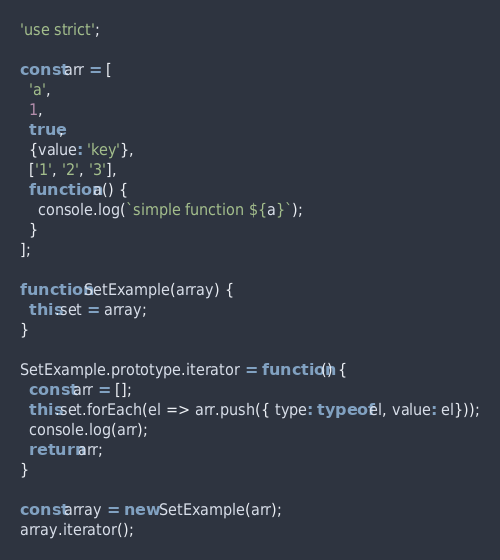<code> <loc_0><loc_0><loc_500><loc_500><_JavaScript_>'use strict';

const arr = [
  'a',
  1,
  true, 
  {value: 'key'},
  ['1', '2', '3'], 
  function a() {
    console.log(`simple function ${a}`);
  }
];

function SetExample(array) {
  this.set = array;
}

SetExample.prototype.iterator = function() {
  const arr = [];
  this.set.forEach(el => arr.push({ type: typeof el, value: el}));
  console.log(arr);
  return arr;
}

const array = new SetExample(arr);
array.iterator();
</code> 